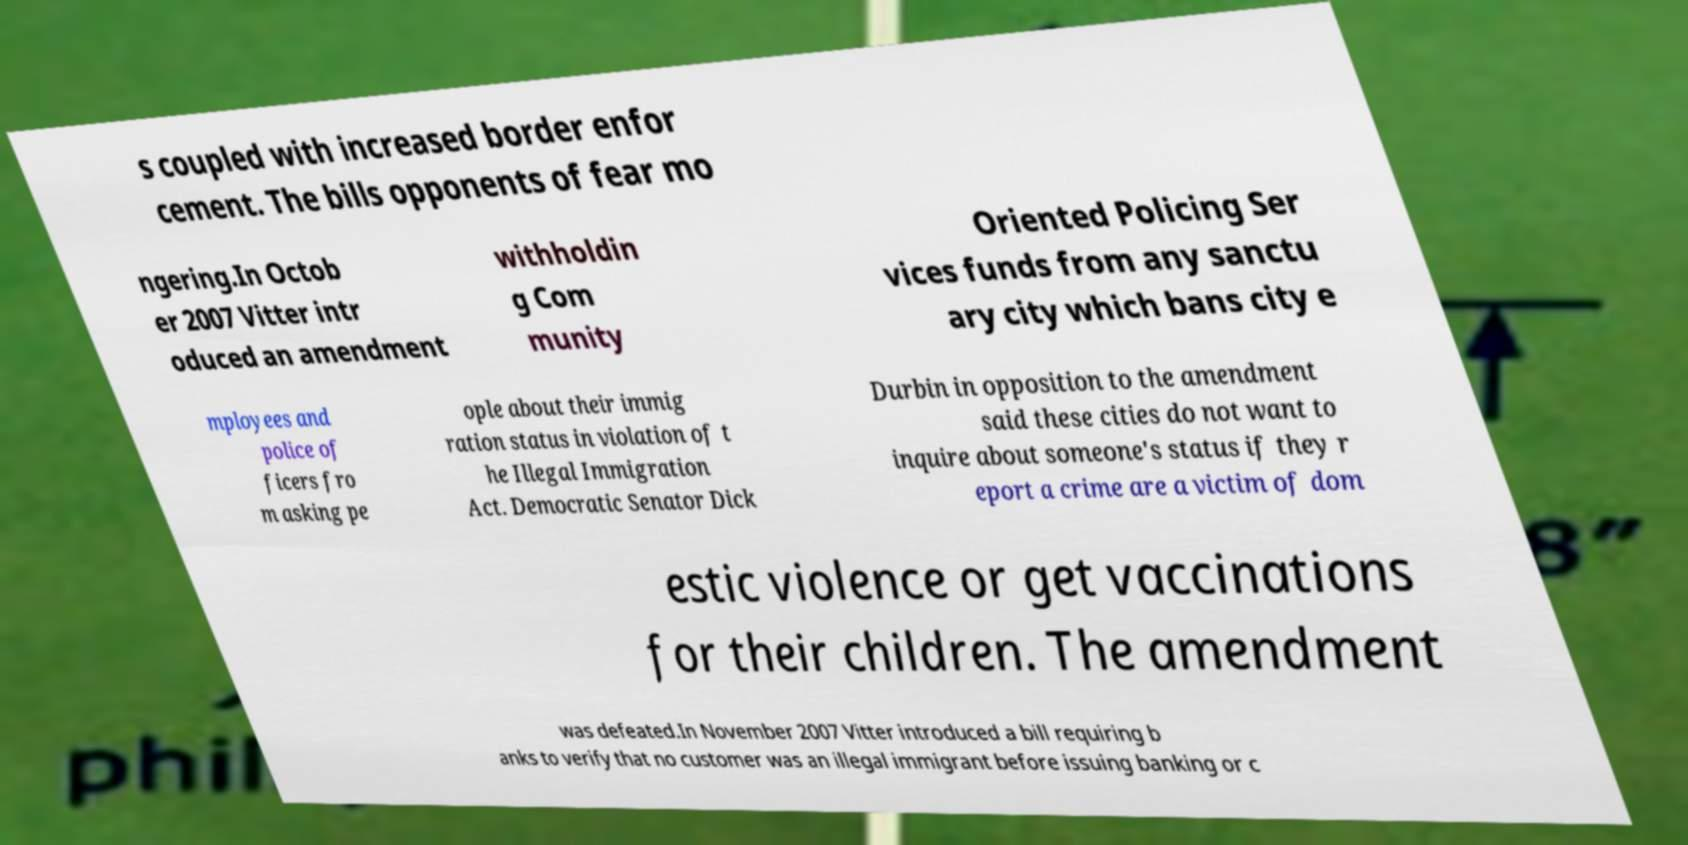Could you extract and type out the text from this image? s coupled with increased border enfor cement. The bills opponents of fear mo ngering.In Octob er 2007 Vitter intr oduced an amendment withholdin g Com munity Oriented Policing Ser vices funds from any sanctu ary city which bans city e mployees and police of ficers fro m asking pe ople about their immig ration status in violation of t he Illegal Immigration Act. Democratic Senator Dick Durbin in opposition to the amendment said these cities do not want to inquire about someone's status if they r eport a crime are a victim of dom estic violence or get vaccinations for their children. The amendment was defeated.In November 2007 Vitter introduced a bill requiring b anks to verify that no customer was an illegal immigrant before issuing banking or c 